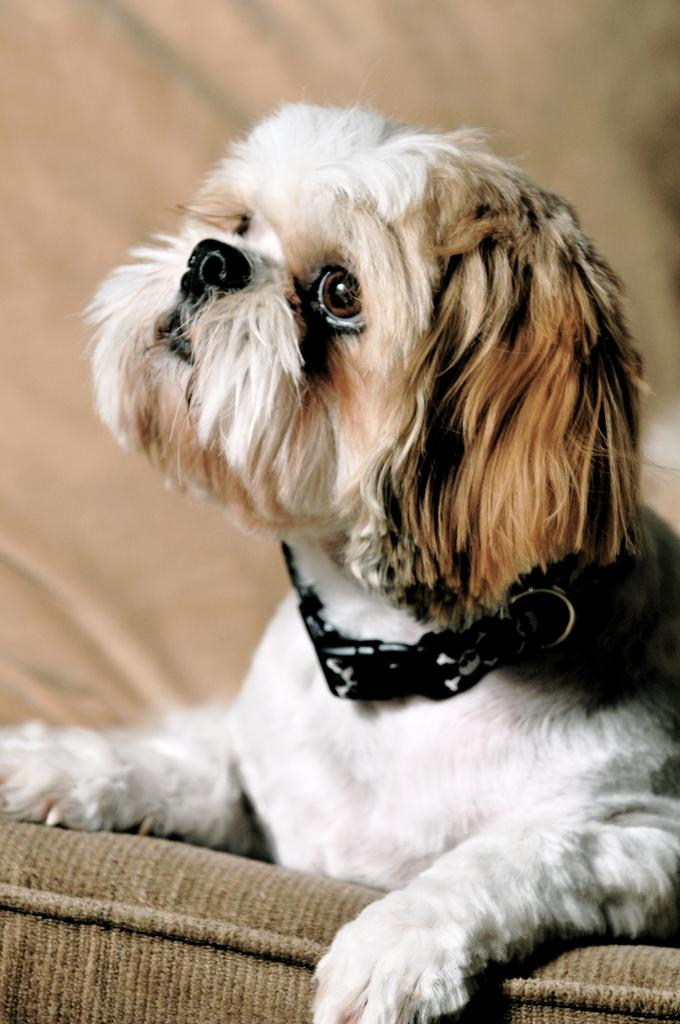What type of animal is present in the image? There is a dog in the image. What is the dog wearing? The dog is wearing a belt. Can you describe the object in the image? Unfortunately, the provided facts do not give any information about the object in the image. How would you describe the background of the image? The background of the image is blurry. What type of instrument is the ghost playing in the image? There is no ghost or instrument present in the image. 